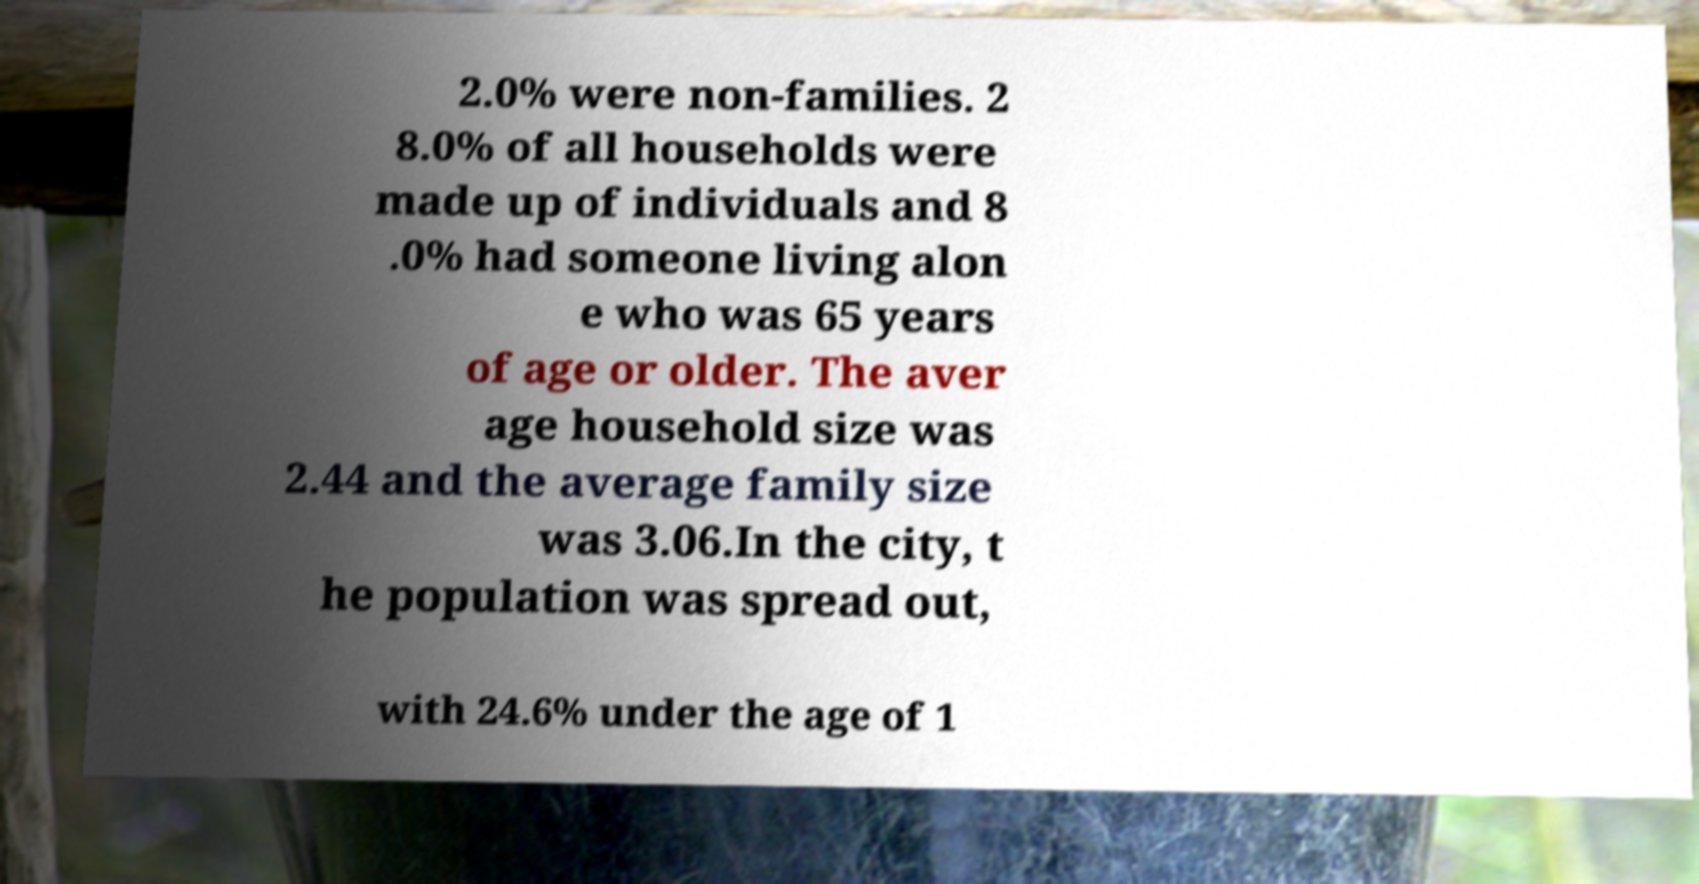For documentation purposes, I need the text within this image transcribed. Could you provide that? 2.0% were non-families. 2 8.0% of all households were made up of individuals and 8 .0% had someone living alon e who was 65 years of age or older. The aver age household size was 2.44 and the average family size was 3.06.In the city, t he population was spread out, with 24.6% under the age of 1 